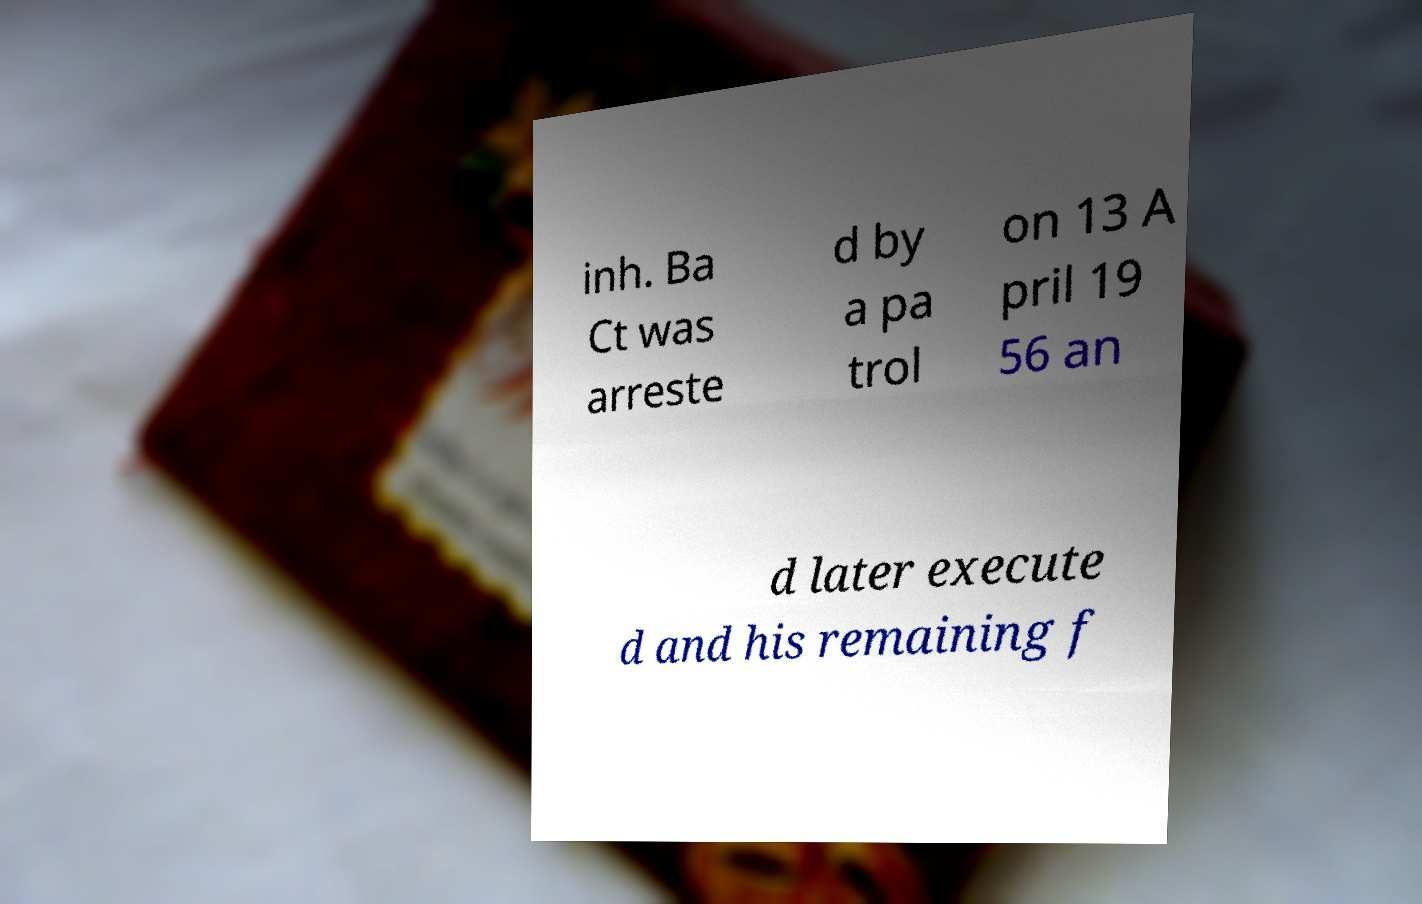Could you assist in decoding the text presented in this image and type it out clearly? inh. Ba Ct was arreste d by a pa trol on 13 A pril 19 56 an d later execute d and his remaining f 